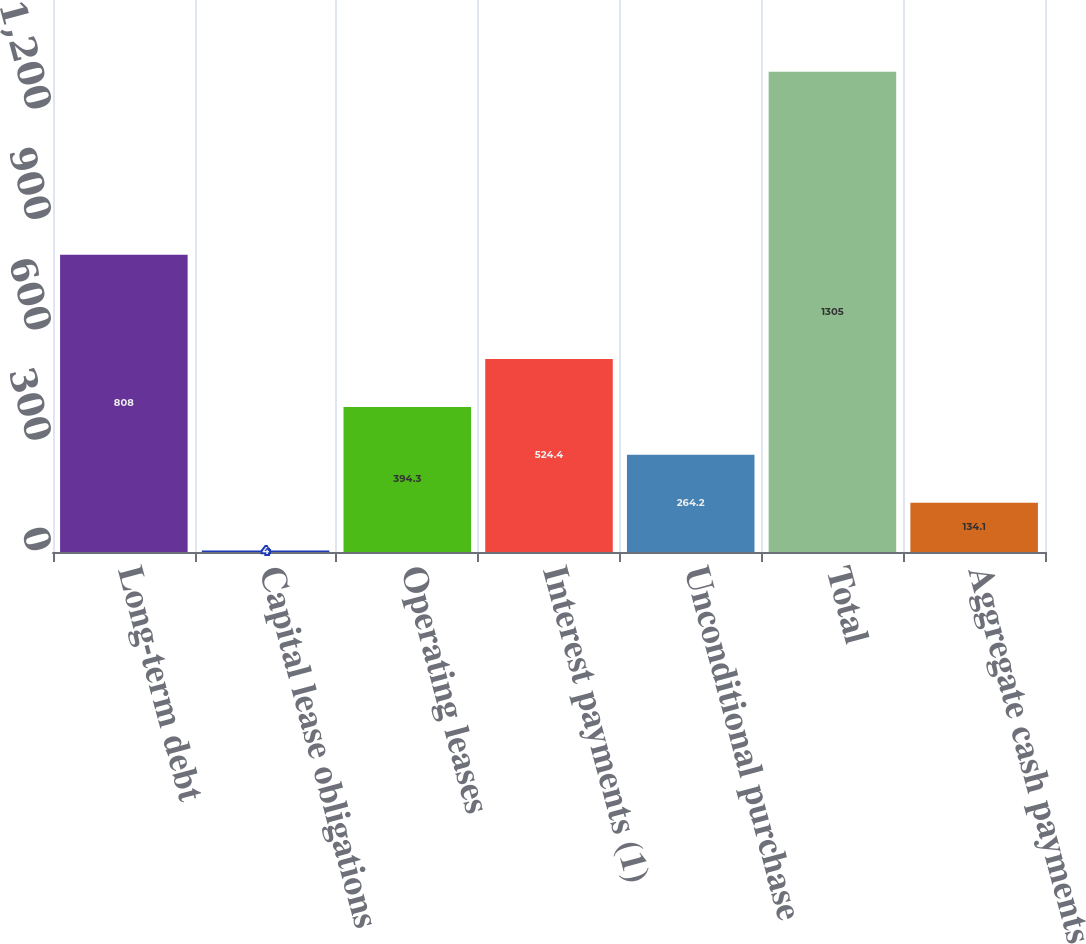Convert chart to OTSL. <chart><loc_0><loc_0><loc_500><loc_500><bar_chart><fcel>Long-term debt<fcel>Capital lease obligations<fcel>Operating leases<fcel>Interest payments (1)<fcel>Unconditional purchase<fcel>Total<fcel>Aggregate cash payments<nl><fcel>808<fcel>4<fcel>394.3<fcel>524.4<fcel>264.2<fcel>1305<fcel>134.1<nl></chart> 